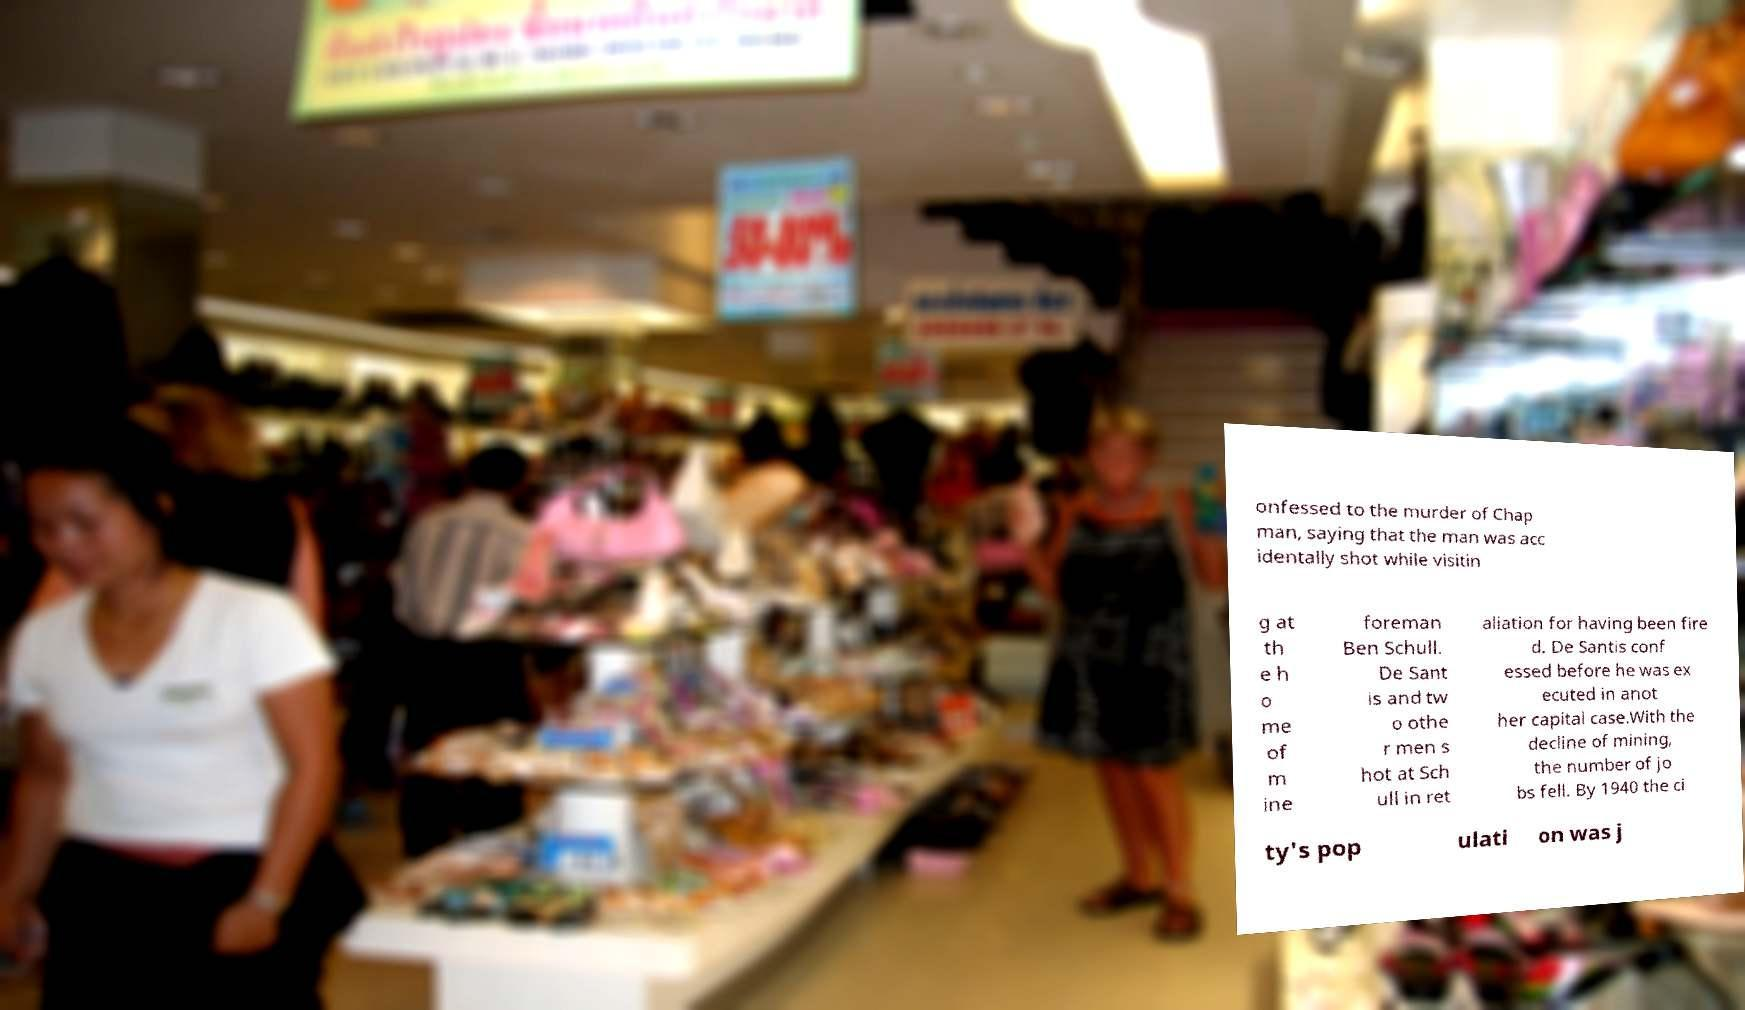There's text embedded in this image that I need extracted. Can you transcribe it verbatim? onfessed to the murder of Chap man, saying that the man was acc identally shot while visitin g at th e h o me of m ine foreman Ben Schull. De Sant is and tw o othe r men s hot at Sch ull in ret aliation for having been fire d. De Santis conf essed before he was ex ecuted in anot her capital case.With the decline of mining, the number of jo bs fell. By 1940 the ci ty's pop ulati on was j 